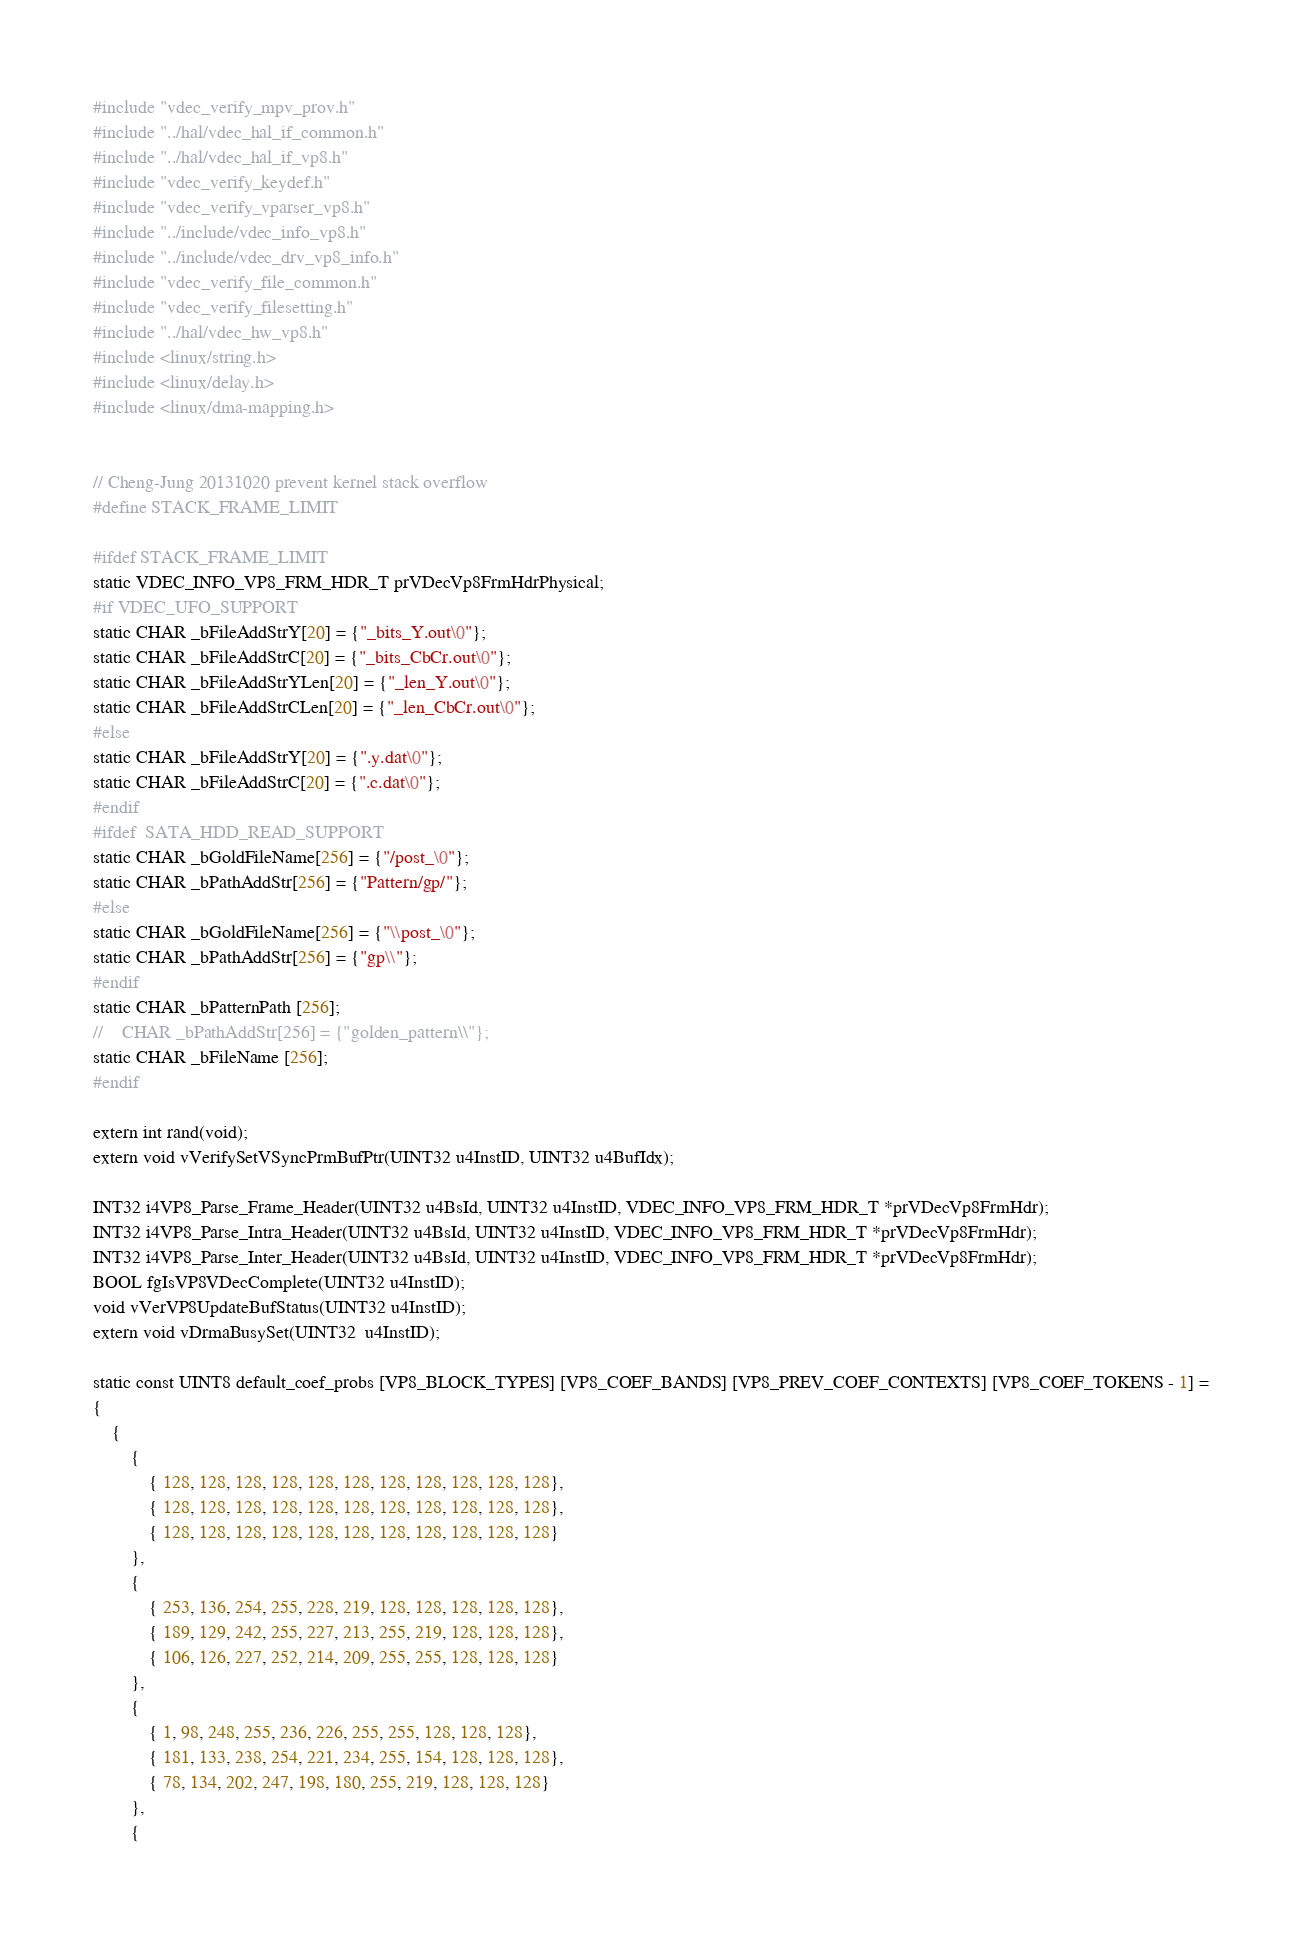<code> <loc_0><loc_0><loc_500><loc_500><_C_>#include "vdec_verify_mpv_prov.h"
#include "../hal/vdec_hal_if_common.h"
#include "../hal/vdec_hal_if_vp8.h"
#include "vdec_verify_keydef.h"
#include "vdec_verify_vparser_vp8.h"
#include "../include/vdec_info_vp8.h"
#include "../include/vdec_drv_vp8_info.h"
#include "vdec_verify_file_common.h"
#include "vdec_verify_filesetting.h"
#include "../hal/vdec_hw_vp8.h"
#include <linux/string.h>
#include <linux/delay.h>
#include <linux/dma-mapping.h>


// Cheng-Jung 20131020 prevent kernel stack overflow
#define STACK_FRAME_LIMIT

#ifdef STACK_FRAME_LIMIT
static VDEC_INFO_VP8_FRM_HDR_T prVDecVp8FrmHdrPhysical;
#if VDEC_UFO_SUPPORT
static CHAR _bFileAddStrY[20] = {"_bits_Y.out\0"};
static CHAR _bFileAddStrC[20] = {"_bits_CbCr.out\0"};
static CHAR _bFileAddStrYLen[20] = {"_len_Y.out\0"};
static CHAR _bFileAddStrCLen[20] = {"_len_CbCr.out\0"};
#else
static CHAR _bFileAddStrY[20] = {".y.dat\0"};
static CHAR _bFileAddStrC[20] = {".c.dat\0"};
#endif
#ifdef  SATA_HDD_READ_SUPPORT
static CHAR _bGoldFileName[256] = {"/post_\0"};
static CHAR _bPathAddStr[256] = {"Pattern/gp/"};
#else
static CHAR _bGoldFileName[256] = {"\\post_\0"};
static CHAR _bPathAddStr[256] = {"gp\\"};
#endif
static CHAR _bPatternPath [256];
//    CHAR _bPathAddStr[256] = {"golden_pattern\\"};
static CHAR _bFileName [256];
#endif

extern int rand(void);
extern void vVerifySetVSyncPrmBufPtr(UINT32 u4InstID, UINT32 u4BufIdx);

INT32 i4VP8_Parse_Frame_Header(UINT32 u4BsId, UINT32 u4InstID, VDEC_INFO_VP8_FRM_HDR_T *prVDecVp8FrmHdr);
INT32 i4VP8_Parse_Intra_Header(UINT32 u4BsId, UINT32 u4InstID, VDEC_INFO_VP8_FRM_HDR_T *prVDecVp8FrmHdr);
INT32 i4VP8_Parse_Inter_Header(UINT32 u4BsId, UINT32 u4InstID, VDEC_INFO_VP8_FRM_HDR_T *prVDecVp8FrmHdr);
BOOL fgIsVP8VDecComplete(UINT32 u4InstID);
void vVerVP8UpdateBufStatus(UINT32 u4InstID);
extern void vDrmaBusySet(UINT32  u4InstID);

static const UINT8 default_coef_probs [VP8_BLOCK_TYPES] [VP8_COEF_BANDS] [VP8_PREV_COEF_CONTEXTS] [VP8_COEF_TOKENS - 1] =
{
    {
        {
            { 128, 128, 128, 128, 128, 128, 128, 128, 128, 128, 128},
            { 128, 128, 128, 128, 128, 128, 128, 128, 128, 128, 128},
            { 128, 128, 128, 128, 128, 128, 128, 128, 128, 128, 128}
        },
        {
            { 253, 136, 254, 255, 228, 219, 128, 128, 128, 128, 128},
            { 189, 129, 242, 255, 227, 213, 255, 219, 128, 128, 128},
            { 106, 126, 227, 252, 214, 209, 255, 255, 128, 128, 128}
        },
        {
            { 1, 98, 248, 255, 236, 226, 255, 255, 128, 128, 128},
            { 181, 133, 238, 254, 221, 234, 255, 154, 128, 128, 128},
            { 78, 134, 202, 247, 198, 180, 255, 219, 128, 128, 128}
        },
        {</code> 